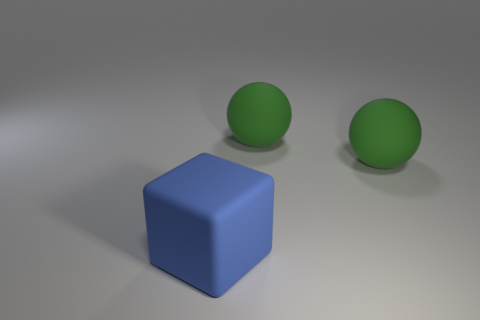Add 1 purple rubber balls. How many objects exist? 4 Subtract all cubes. How many objects are left? 2 Subtract all green balls. Subtract all blue objects. How many objects are left? 0 Add 2 large matte things. How many large matte things are left? 5 Add 1 small gray rubber blocks. How many small gray rubber blocks exist? 1 Subtract 0 brown spheres. How many objects are left? 3 